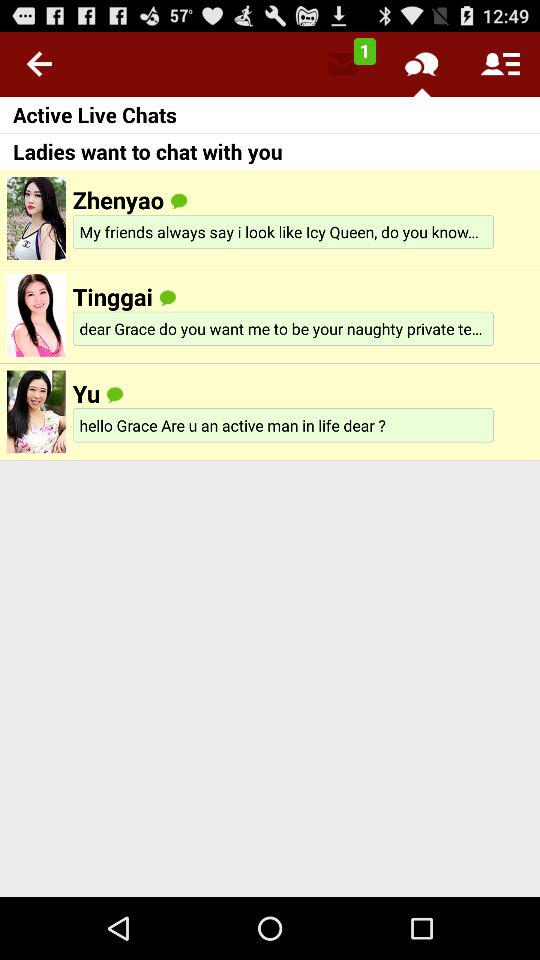How many active live chats are there?
Answer the question using a single word or phrase. 3 